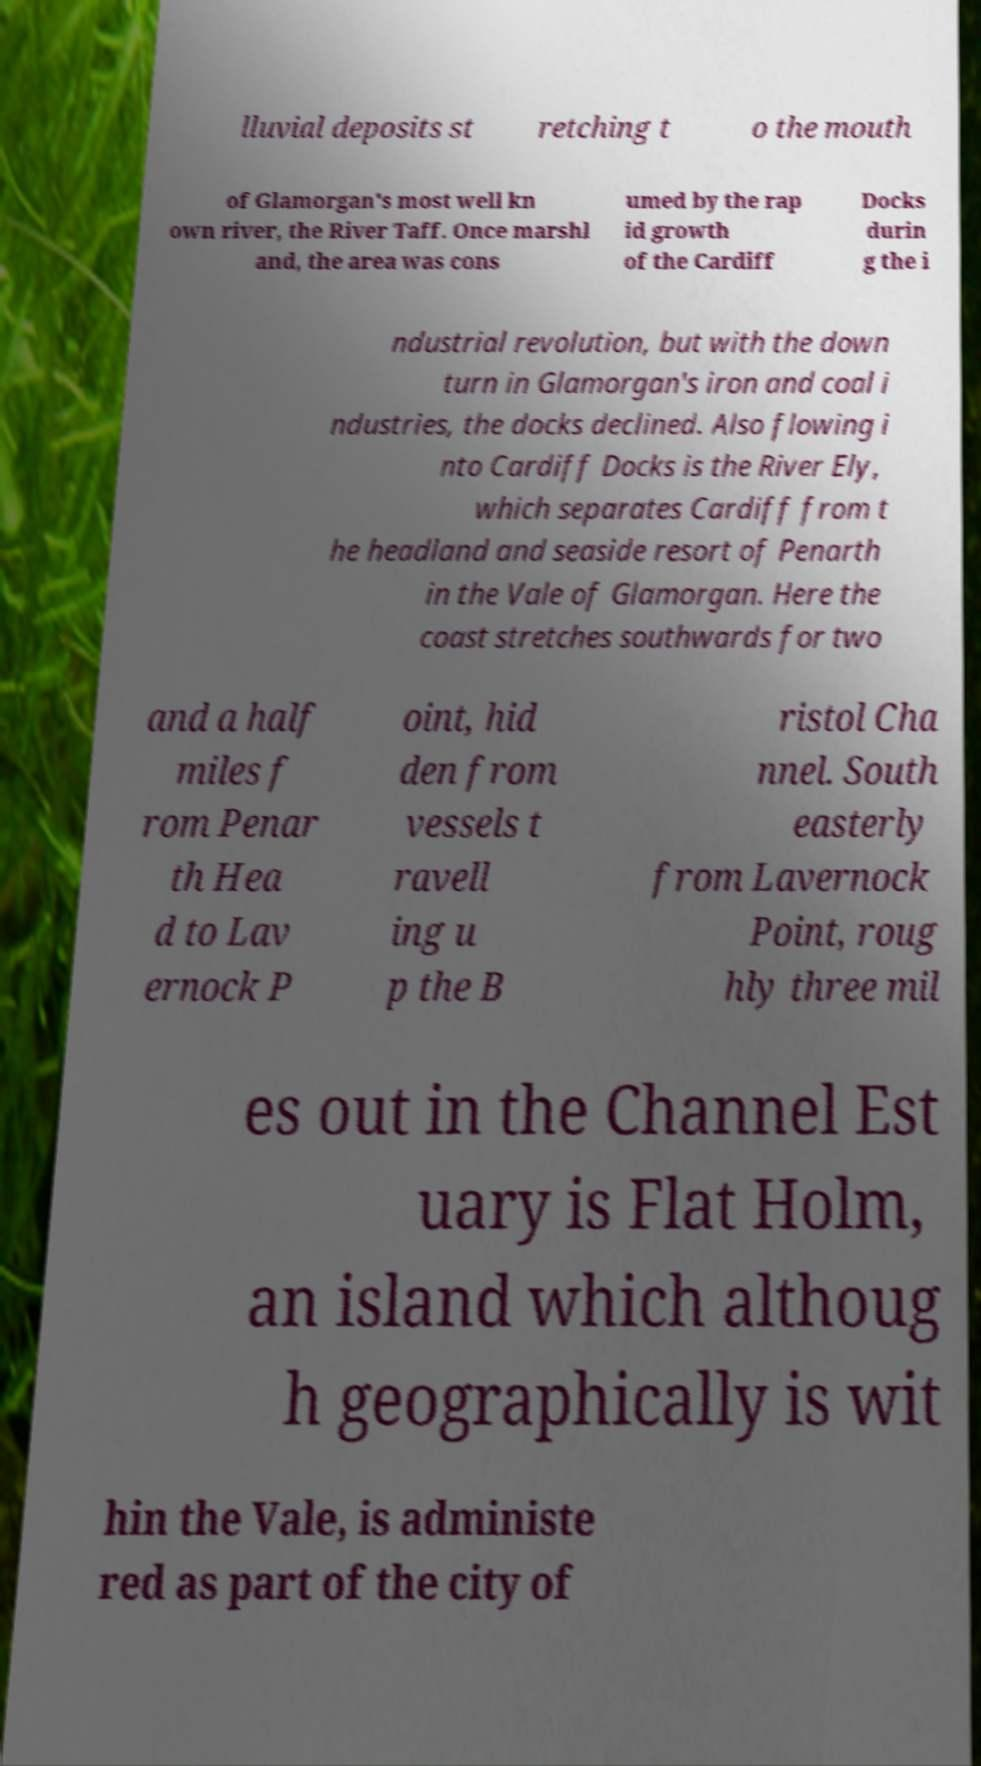Please identify and transcribe the text found in this image. lluvial deposits st retching t o the mouth of Glamorgan's most well kn own river, the River Taff. Once marshl and, the area was cons umed by the rap id growth of the Cardiff Docks durin g the i ndustrial revolution, but with the down turn in Glamorgan's iron and coal i ndustries, the docks declined. Also flowing i nto Cardiff Docks is the River Ely, which separates Cardiff from t he headland and seaside resort of Penarth in the Vale of Glamorgan. Here the coast stretches southwards for two and a half miles f rom Penar th Hea d to Lav ernock P oint, hid den from vessels t ravell ing u p the B ristol Cha nnel. South easterly from Lavernock Point, roug hly three mil es out in the Channel Est uary is Flat Holm, an island which althoug h geographically is wit hin the Vale, is administe red as part of the city of 